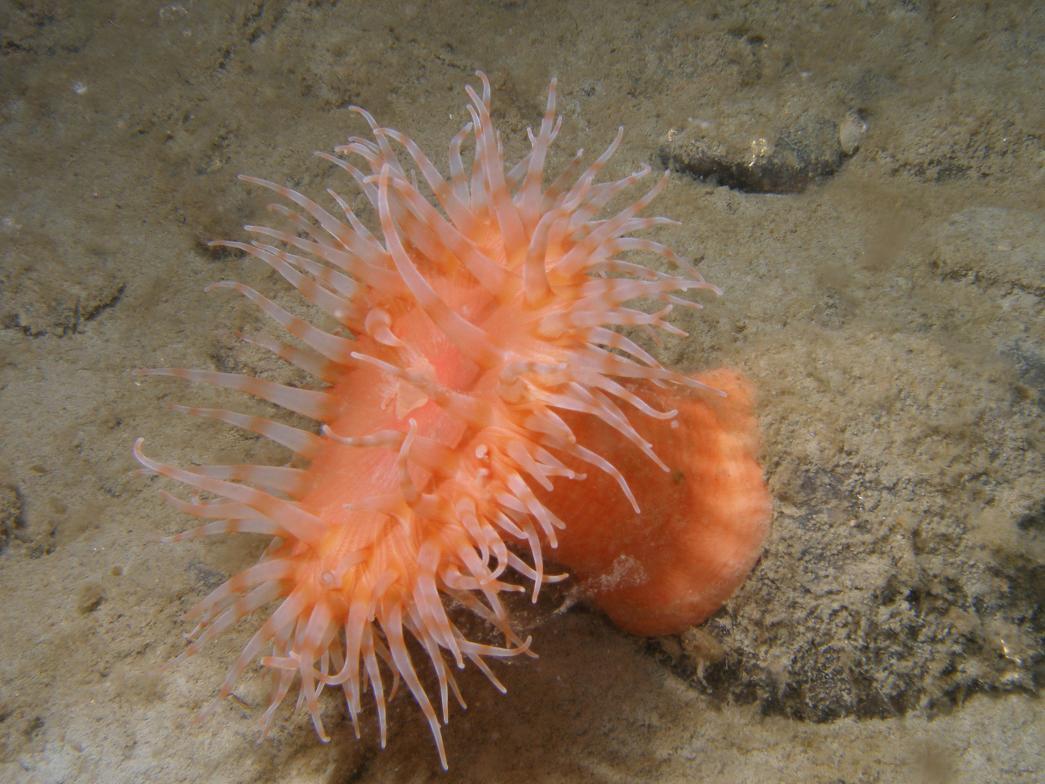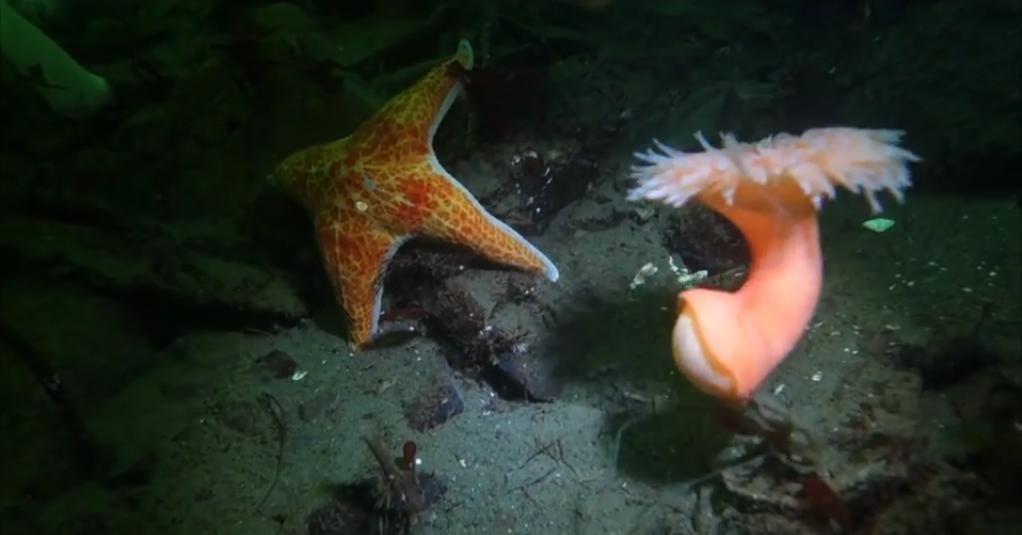The first image is the image on the left, the second image is the image on the right. Given the left and right images, does the statement "An image contains at least three clown fish." hold true? Answer yes or no. No. The first image is the image on the left, the second image is the image on the right. Analyze the images presented: Is the assertion "Several fish are swimming in one of the images." valid? Answer yes or no. No. 